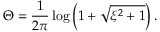Convert formula to latex. <formula><loc_0><loc_0><loc_500><loc_500>\Theta = \frac { 1 } { 2 \pi } \log \left ( 1 + \sqrt { \xi ^ { 2 } + 1 } \right ) .</formula> 